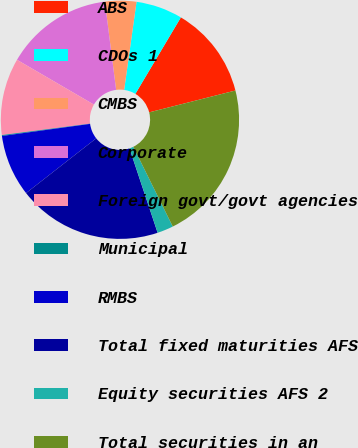Convert chart. <chart><loc_0><loc_0><loc_500><loc_500><pie_chart><fcel>ABS<fcel>CDOs 1<fcel>CMBS<fcel>Corporate<fcel>Foreign govt/govt agencies<fcel>Municipal<fcel>RMBS<fcel>Total fixed maturities AFS<fcel>Equity securities AFS 2<fcel>Total securities in an<nl><fcel>12.51%<fcel>6.32%<fcel>4.25%<fcel>14.58%<fcel>10.45%<fcel>0.12%<fcel>8.38%<fcel>19.57%<fcel>2.19%<fcel>21.64%<nl></chart> 